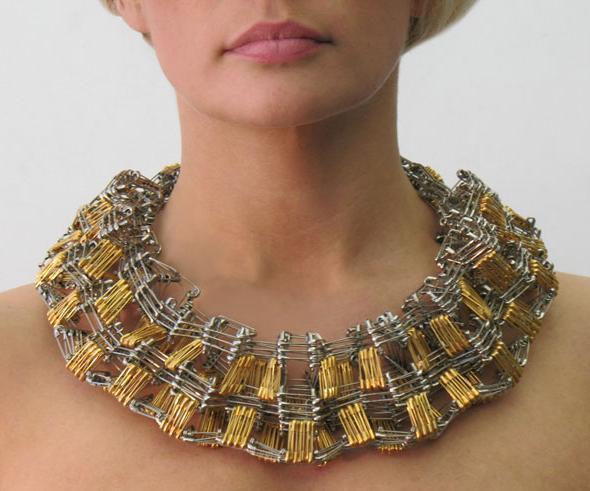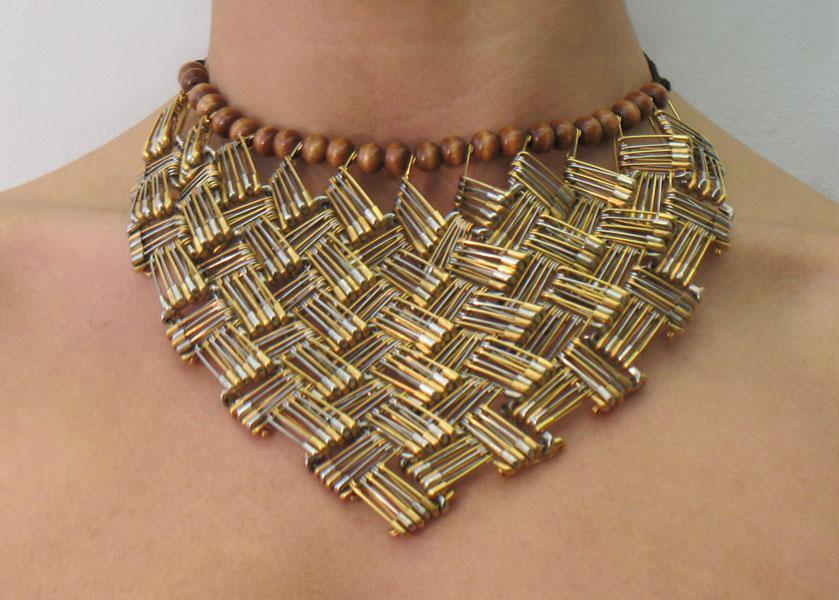The first image is the image on the left, the second image is the image on the right. Assess this claim about the two images: "One of the necklaces is not dangling around a neck.". Correct or not? Answer yes or no. No. The first image is the image on the left, the second image is the image on the right. Evaluate the accuracy of this statement regarding the images: "Both images show a model wearing a necklace.". Is it true? Answer yes or no. Yes. 